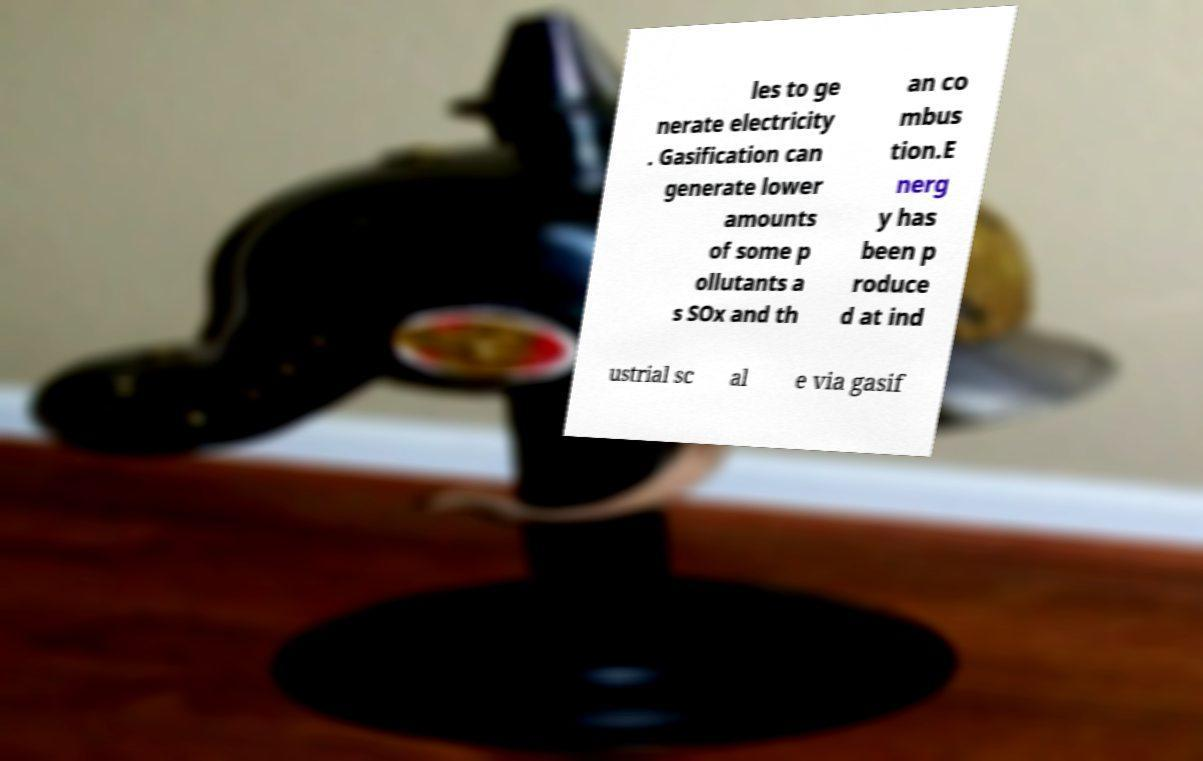Please identify and transcribe the text found in this image. les to ge nerate electricity . Gasification can generate lower amounts of some p ollutants a s SOx and th an co mbus tion.E nerg y has been p roduce d at ind ustrial sc al e via gasif 